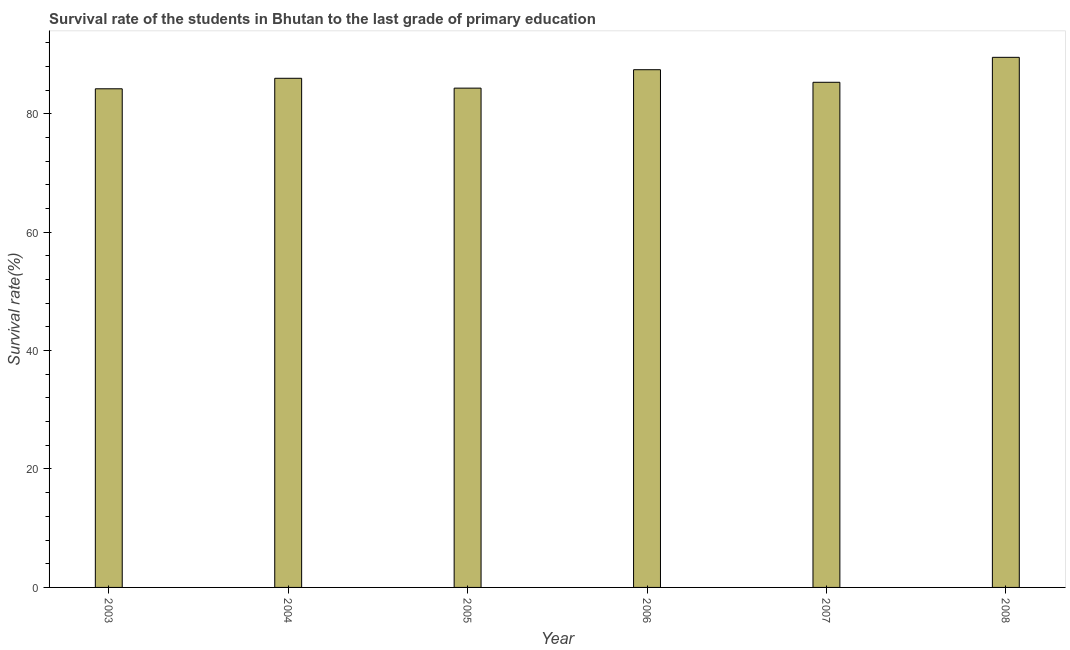Does the graph contain any zero values?
Keep it short and to the point. No. What is the title of the graph?
Ensure brevity in your answer.  Survival rate of the students in Bhutan to the last grade of primary education. What is the label or title of the Y-axis?
Give a very brief answer. Survival rate(%). What is the survival rate in primary education in 2008?
Provide a succinct answer. 89.52. Across all years, what is the maximum survival rate in primary education?
Keep it short and to the point. 89.52. Across all years, what is the minimum survival rate in primary education?
Your answer should be very brief. 84.21. In which year was the survival rate in primary education maximum?
Ensure brevity in your answer.  2008. What is the sum of the survival rate in primary education?
Keep it short and to the point. 516.78. What is the difference between the survival rate in primary education in 2003 and 2008?
Make the answer very short. -5.31. What is the average survival rate in primary education per year?
Provide a short and direct response. 86.13. What is the median survival rate in primary education?
Make the answer very short. 85.65. In how many years, is the survival rate in primary education greater than 72 %?
Provide a short and direct response. 6. Do a majority of the years between 2003 and 2008 (inclusive) have survival rate in primary education greater than 12 %?
Your answer should be compact. Yes. What is the ratio of the survival rate in primary education in 2003 to that in 2007?
Make the answer very short. 0.99. What is the difference between the highest and the second highest survival rate in primary education?
Make the answer very short. 2.09. What is the difference between the highest and the lowest survival rate in primary education?
Give a very brief answer. 5.31. In how many years, is the survival rate in primary education greater than the average survival rate in primary education taken over all years?
Offer a terse response. 2. What is the difference between two consecutive major ticks on the Y-axis?
Ensure brevity in your answer.  20. Are the values on the major ticks of Y-axis written in scientific E-notation?
Your response must be concise. No. What is the Survival rate(%) in 2003?
Give a very brief answer. 84.21. What is the Survival rate(%) in 2004?
Offer a terse response. 85.99. What is the Survival rate(%) of 2005?
Your answer should be compact. 84.32. What is the Survival rate(%) in 2006?
Make the answer very short. 87.43. What is the Survival rate(%) in 2007?
Your answer should be compact. 85.31. What is the Survival rate(%) in 2008?
Your response must be concise. 89.52. What is the difference between the Survival rate(%) in 2003 and 2004?
Make the answer very short. -1.77. What is the difference between the Survival rate(%) in 2003 and 2005?
Your answer should be very brief. -0.11. What is the difference between the Survival rate(%) in 2003 and 2006?
Offer a very short reply. -3.22. What is the difference between the Survival rate(%) in 2003 and 2007?
Keep it short and to the point. -1.1. What is the difference between the Survival rate(%) in 2003 and 2008?
Offer a terse response. -5.31. What is the difference between the Survival rate(%) in 2004 and 2005?
Offer a terse response. 1.66. What is the difference between the Survival rate(%) in 2004 and 2006?
Make the answer very short. -1.45. What is the difference between the Survival rate(%) in 2004 and 2007?
Your answer should be compact. 0.68. What is the difference between the Survival rate(%) in 2004 and 2008?
Your answer should be very brief. -3.54. What is the difference between the Survival rate(%) in 2005 and 2006?
Provide a short and direct response. -3.11. What is the difference between the Survival rate(%) in 2005 and 2007?
Give a very brief answer. -0.99. What is the difference between the Survival rate(%) in 2005 and 2008?
Provide a succinct answer. -5.2. What is the difference between the Survival rate(%) in 2006 and 2007?
Your response must be concise. 2.12. What is the difference between the Survival rate(%) in 2006 and 2008?
Your answer should be compact. -2.09. What is the difference between the Survival rate(%) in 2007 and 2008?
Your response must be concise. -4.22. What is the ratio of the Survival rate(%) in 2003 to that in 2006?
Provide a succinct answer. 0.96. What is the ratio of the Survival rate(%) in 2003 to that in 2008?
Your response must be concise. 0.94. What is the ratio of the Survival rate(%) in 2004 to that in 2005?
Your answer should be compact. 1.02. What is the ratio of the Survival rate(%) in 2004 to that in 2007?
Your answer should be compact. 1.01. What is the ratio of the Survival rate(%) in 2004 to that in 2008?
Give a very brief answer. 0.96. What is the ratio of the Survival rate(%) in 2005 to that in 2007?
Your answer should be very brief. 0.99. What is the ratio of the Survival rate(%) in 2005 to that in 2008?
Provide a short and direct response. 0.94. What is the ratio of the Survival rate(%) in 2007 to that in 2008?
Your answer should be compact. 0.95. 